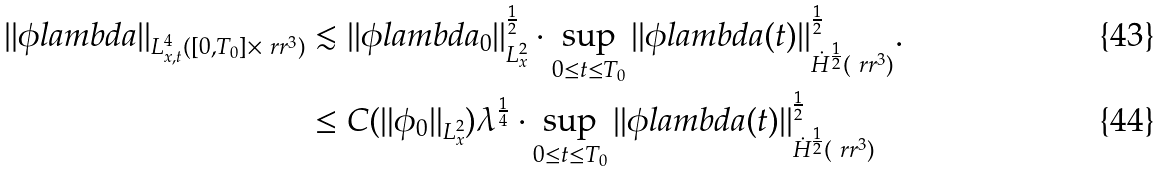Convert formula to latex. <formula><loc_0><loc_0><loc_500><loc_500>| | \phi l a m b d a | | _ { L ^ { 4 } _ { x , t } ( [ 0 , T _ { 0 } ] \times \ r r ^ { 3 } ) } & \lesssim | | \phi l a m b d a _ { 0 } | | ^ { \frac { 1 } { 2 } } _ { L ^ { 2 } _ { x } } \cdot \sup _ { 0 \leq t \leq T _ { 0 } } | | \phi l a m b d a ( t ) | | _ { \dot { H } ^ { \frac { 1 } { 2 } } ( \ r r ^ { 3 } ) } ^ { \frac { 1 } { 2 } } . \\ & \leq C ( \| \phi _ { 0 } \| _ { L ^ { 2 } _ { x } } ) \lambda ^ { \frac { 1 } { 4 } } \cdot \sup _ { 0 \leq t \leq T _ { 0 } } | | \phi l a m b d a ( t ) | | ^ { \frac { 1 } { 2 } } _ { \dot { H } ^ { \frac { 1 } { 2 } } ( \ r r ^ { 3 } ) }</formula> 